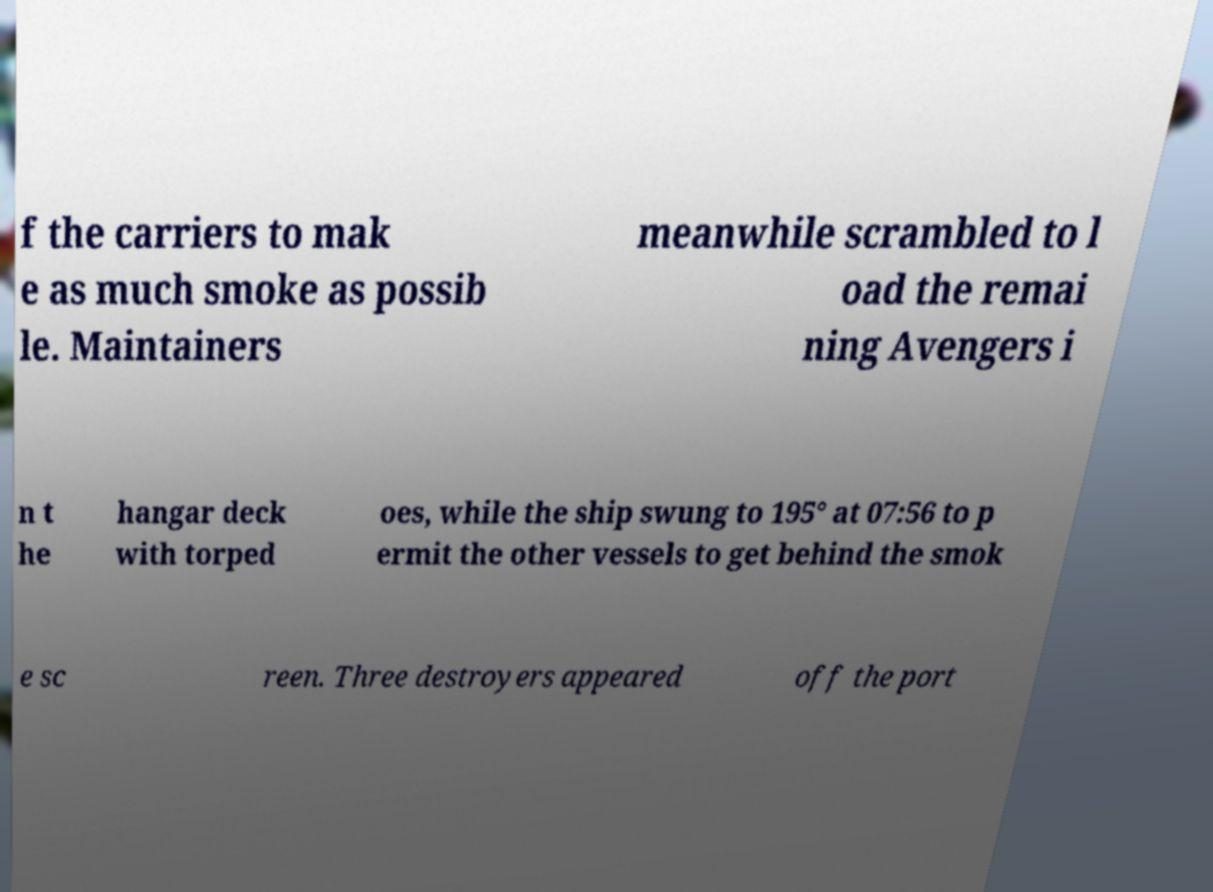Can you read and provide the text displayed in the image?This photo seems to have some interesting text. Can you extract and type it out for me? f the carriers to mak e as much smoke as possib le. Maintainers meanwhile scrambled to l oad the remai ning Avengers i n t he hangar deck with torped oes, while the ship swung to 195° at 07:56 to p ermit the other vessels to get behind the smok e sc reen. Three destroyers appeared off the port 